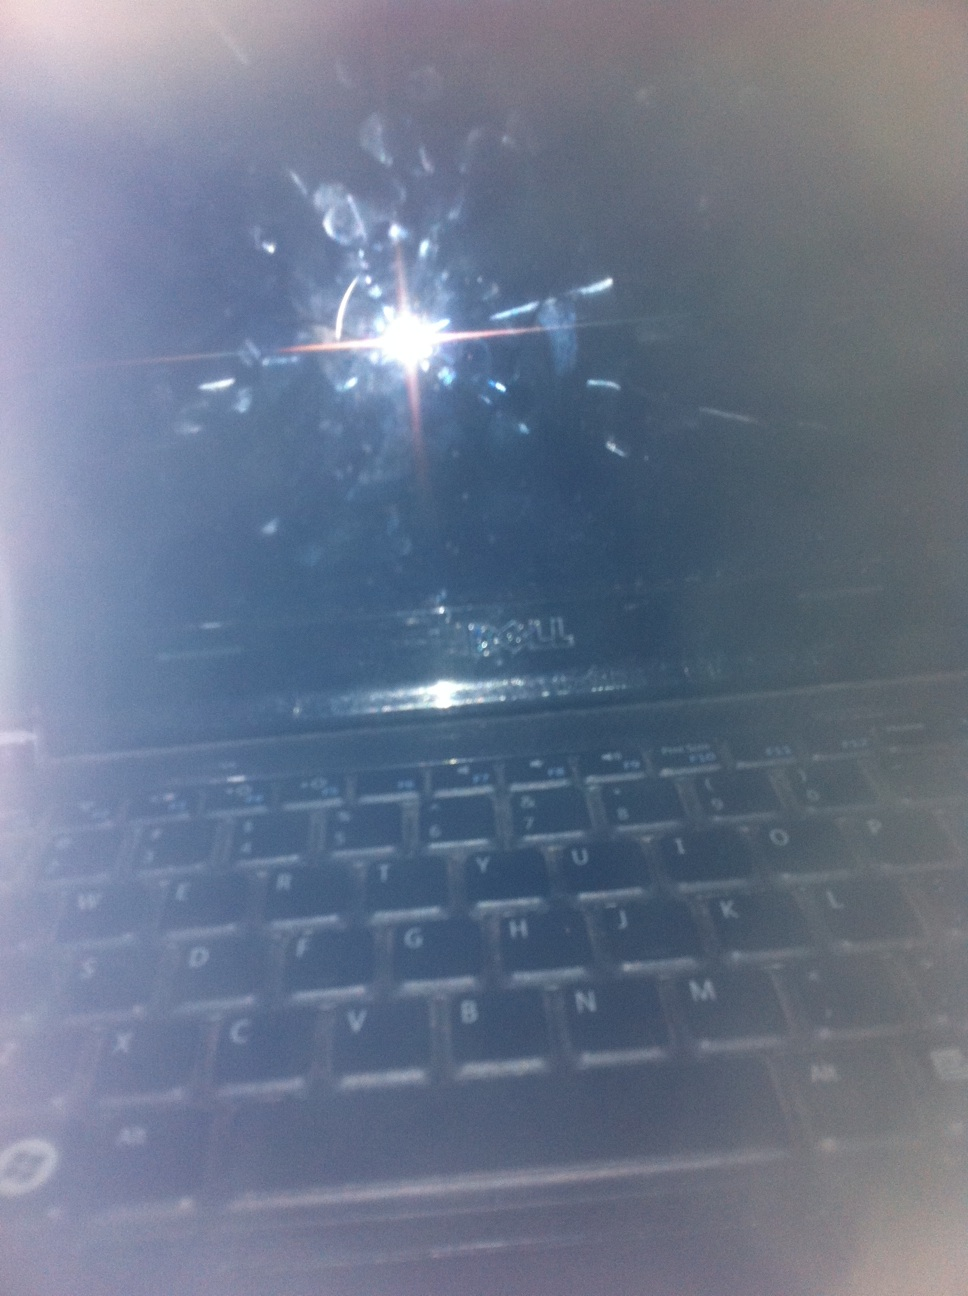Generate an extremely detailed technical analysis of this laptop, focusing on its design and usability. This laptop, identified by its branding as a Dell model, features a compact and sturdy design. The keyboard layout adheres to a standard QWERTY configuration with well-spaced keys that provide a tactile response, suggesting ease of typing for prolonged periods. Notably, the upper surface of the screen is severely smudged, indicating frequent manual interaction, possibly due to its touchscreen functionality. The absence of an active display in this image points towards either a powered-off state or a system currently in sleep mode. The reflective glare on the screen suggests that it may not have an anti-glare coating, which can affect usability under direct lighting conditions. Overall, the laptop appears to be a robust device suitable for regular tasks, although the maintenance of the screen cleanliness might be an area of improvement for user experience. 